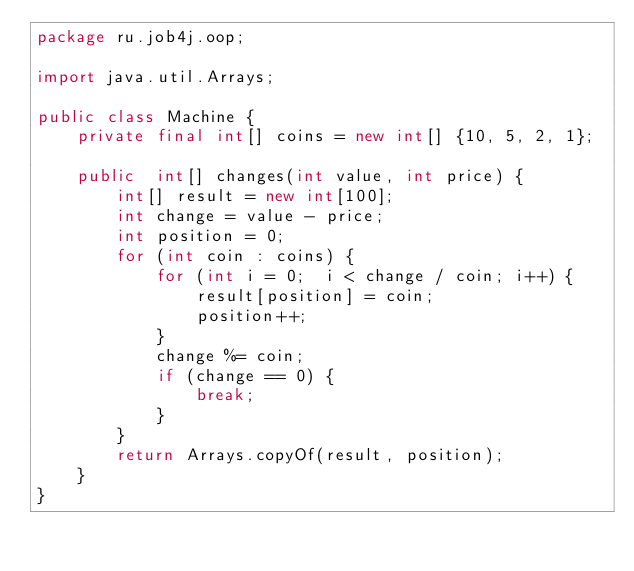<code> <loc_0><loc_0><loc_500><loc_500><_Java_>package ru.job4j.oop;

import java.util.Arrays;

public class Machine {
    private final int[] coins = new int[] {10, 5, 2, 1};

    public  int[] changes(int value, int price) {
        int[] result = new int[100];
        int change = value - price;
        int position = 0;
        for (int coin : coins) {
            for (int i = 0;  i < change / coin; i++) {
                result[position] = coin;
                position++;
            }
            change %= coin;
            if (change == 0) {
                break;
            }
        }
        return Arrays.copyOf(result, position);
    }
}
</code> 